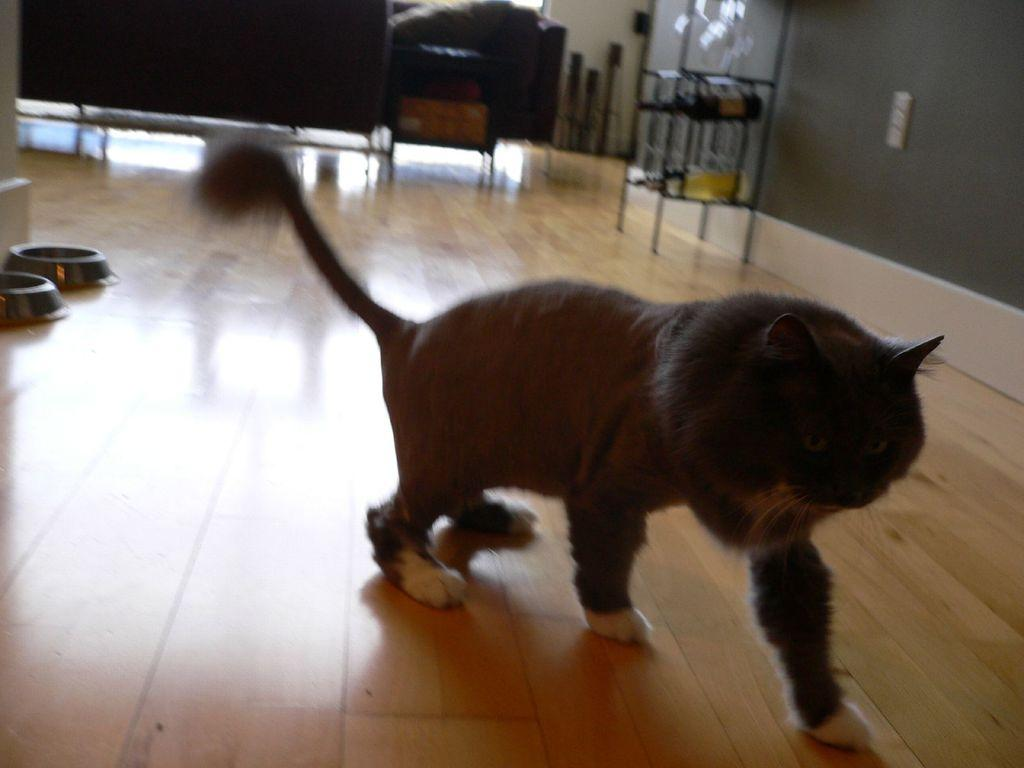What type of animal can be seen in the image? There is a cat in the image. What items are present for the cat's care? There are pet feeding bowls in the image. What is stored in the wine rack in the image? There are wine bottles in a rack in the image. Can you describe the background of the image? There are objects visible in the background of the image. How many frogs are sitting on the swing in the image? There are no frogs or swings present in the image. 